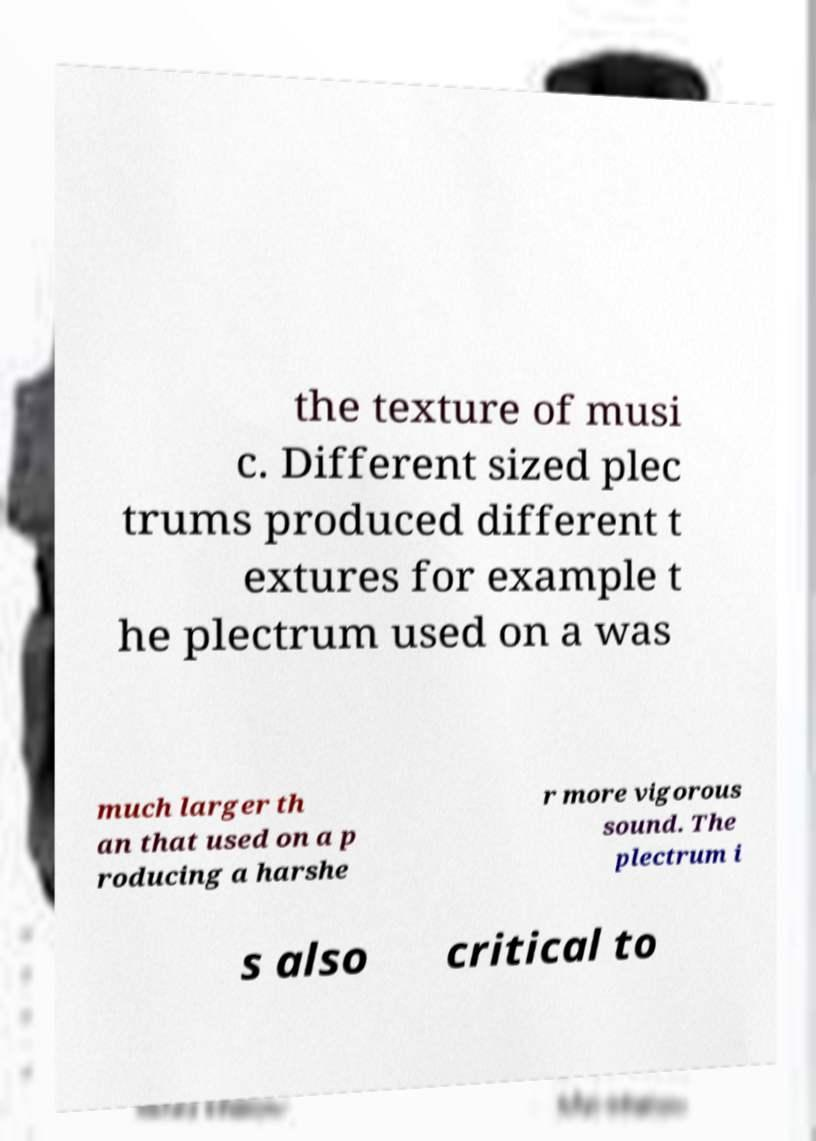Please identify and transcribe the text found in this image. the texture of musi c. Different sized plec trums produced different t extures for example t he plectrum used on a was much larger th an that used on a p roducing a harshe r more vigorous sound. The plectrum i s also critical to 